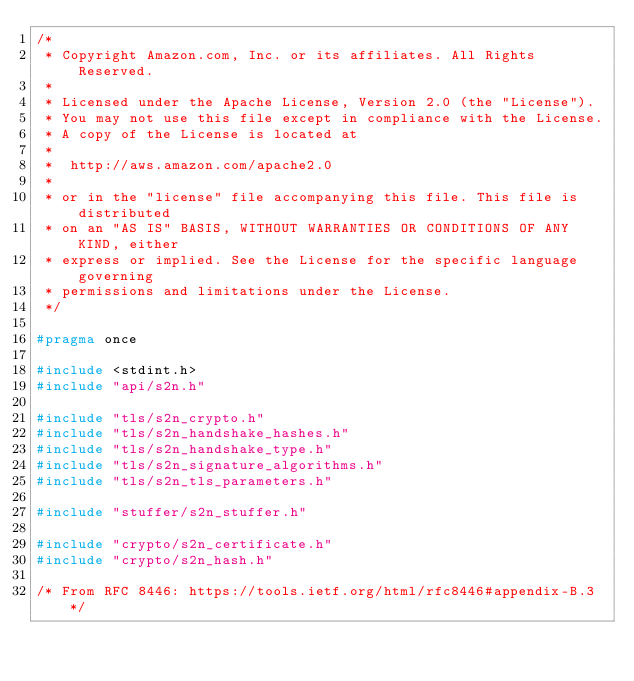<code> <loc_0><loc_0><loc_500><loc_500><_C_>/*
 * Copyright Amazon.com, Inc. or its affiliates. All Rights Reserved.
 *
 * Licensed under the Apache License, Version 2.0 (the "License").
 * You may not use this file except in compliance with the License.
 * A copy of the License is located at
 *
 *  http://aws.amazon.com/apache2.0
 *
 * or in the "license" file accompanying this file. This file is distributed
 * on an "AS IS" BASIS, WITHOUT WARRANTIES OR CONDITIONS OF ANY KIND, either
 * express or implied. See the License for the specific language governing
 * permissions and limitations under the License.
 */

#pragma once

#include <stdint.h>
#include "api/s2n.h"

#include "tls/s2n_crypto.h"
#include "tls/s2n_handshake_hashes.h"
#include "tls/s2n_handshake_type.h"
#include "tls/s2n_signature_algorithms.h"
#include "tls/s2n_tls_parameters.h"

#include "stuffer/s2n_stuffer.h"

#include "crypto/s2n_certificate.h"
#include "crypto/s2n_hash.h"

/* From RFC 8446: https://tools.ietf.org/html/rfc8446#appendix-B.3 */</code> 